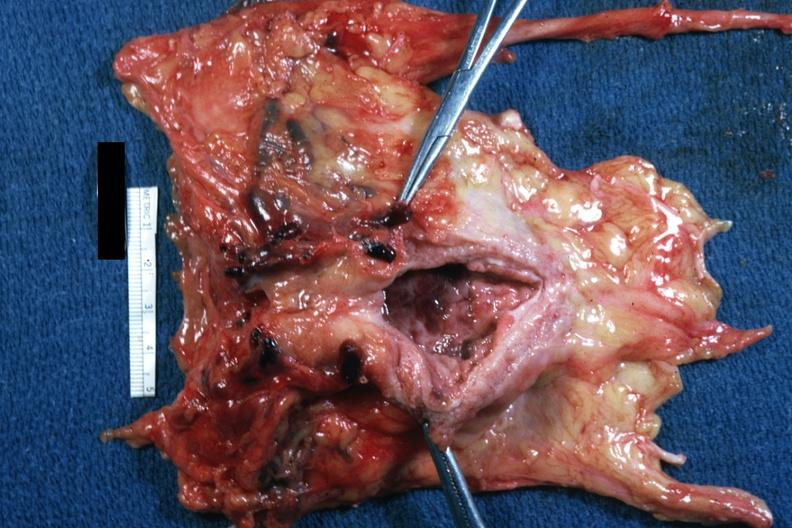does this image show numerous large thrombi?
Answer the question using a single word or phrase. Yes 